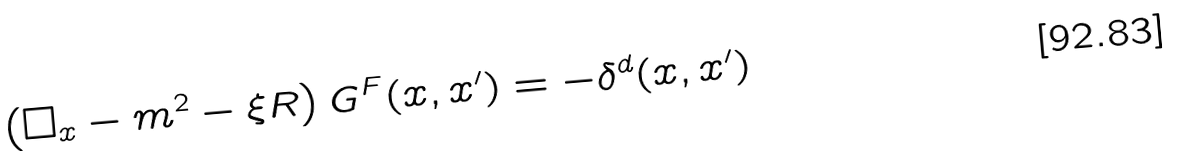<formula> <loc_0><loc_0><loc_500><loc_500>\left ( \Box _ { x } - m ^ { 2 } - \xi R \right ) G ^ { F } ( x , x ^ { \prime } ) = - \delta ^ { d } ( x , x ^ { \prime } )</formula> 